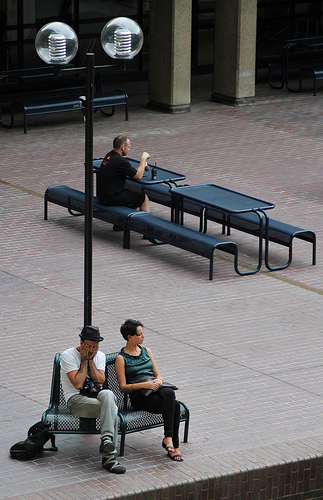Please provide a short description for this region: [0.24, 0.61, 0.57, 0.95]. This area captures two individuals comfortably seated on a public bench, engaged in individual activities under a daytime setting. 